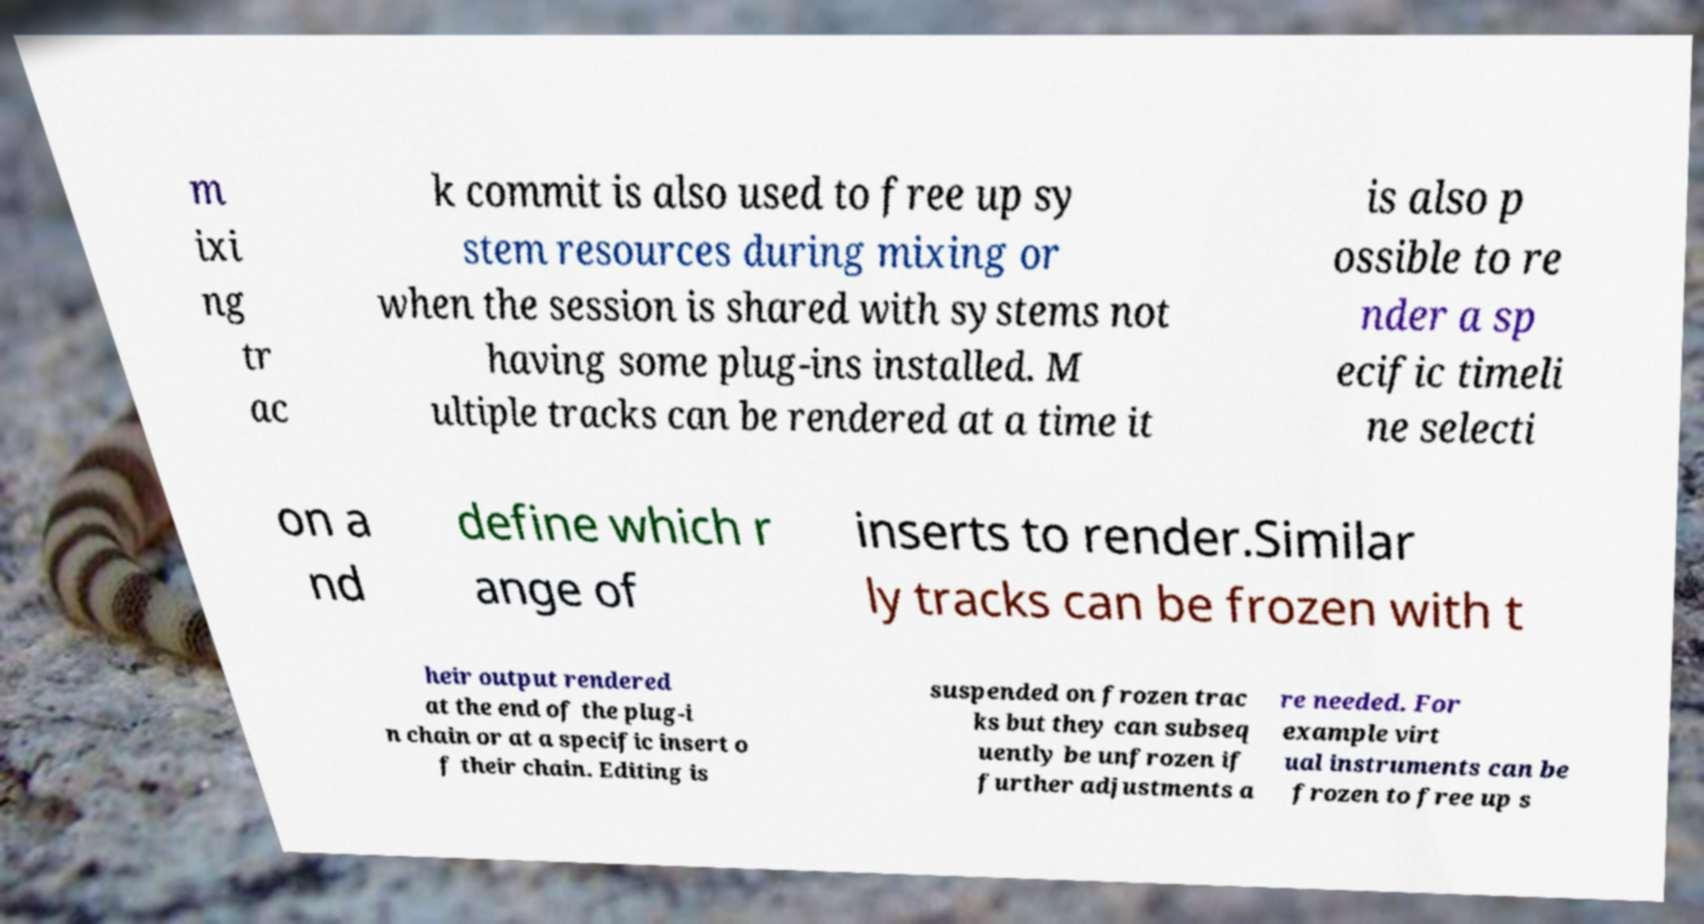What messages or text are displayed in this image? I need them in a readable, typed format. m ixi ng tr ac k commit is also used to free up sy stem resources during mixing or when the session is shared with systems not having some plug-ins installed. M ultiple tracks can be rendered at a time it is also p ossible to re nder a sp ecific timeli ne selecti on a nd define which r ange of inserts to render.Similar ly tracks can be frozen with t heir output rendered at the end of the plug-i n chain or at a specific insert o f their chain. Editing is suspended on frozen trac ks but they can subseq uently be unfrozen if further adjustments a re needed. For example virt ual instruments can be frozen to free up s 